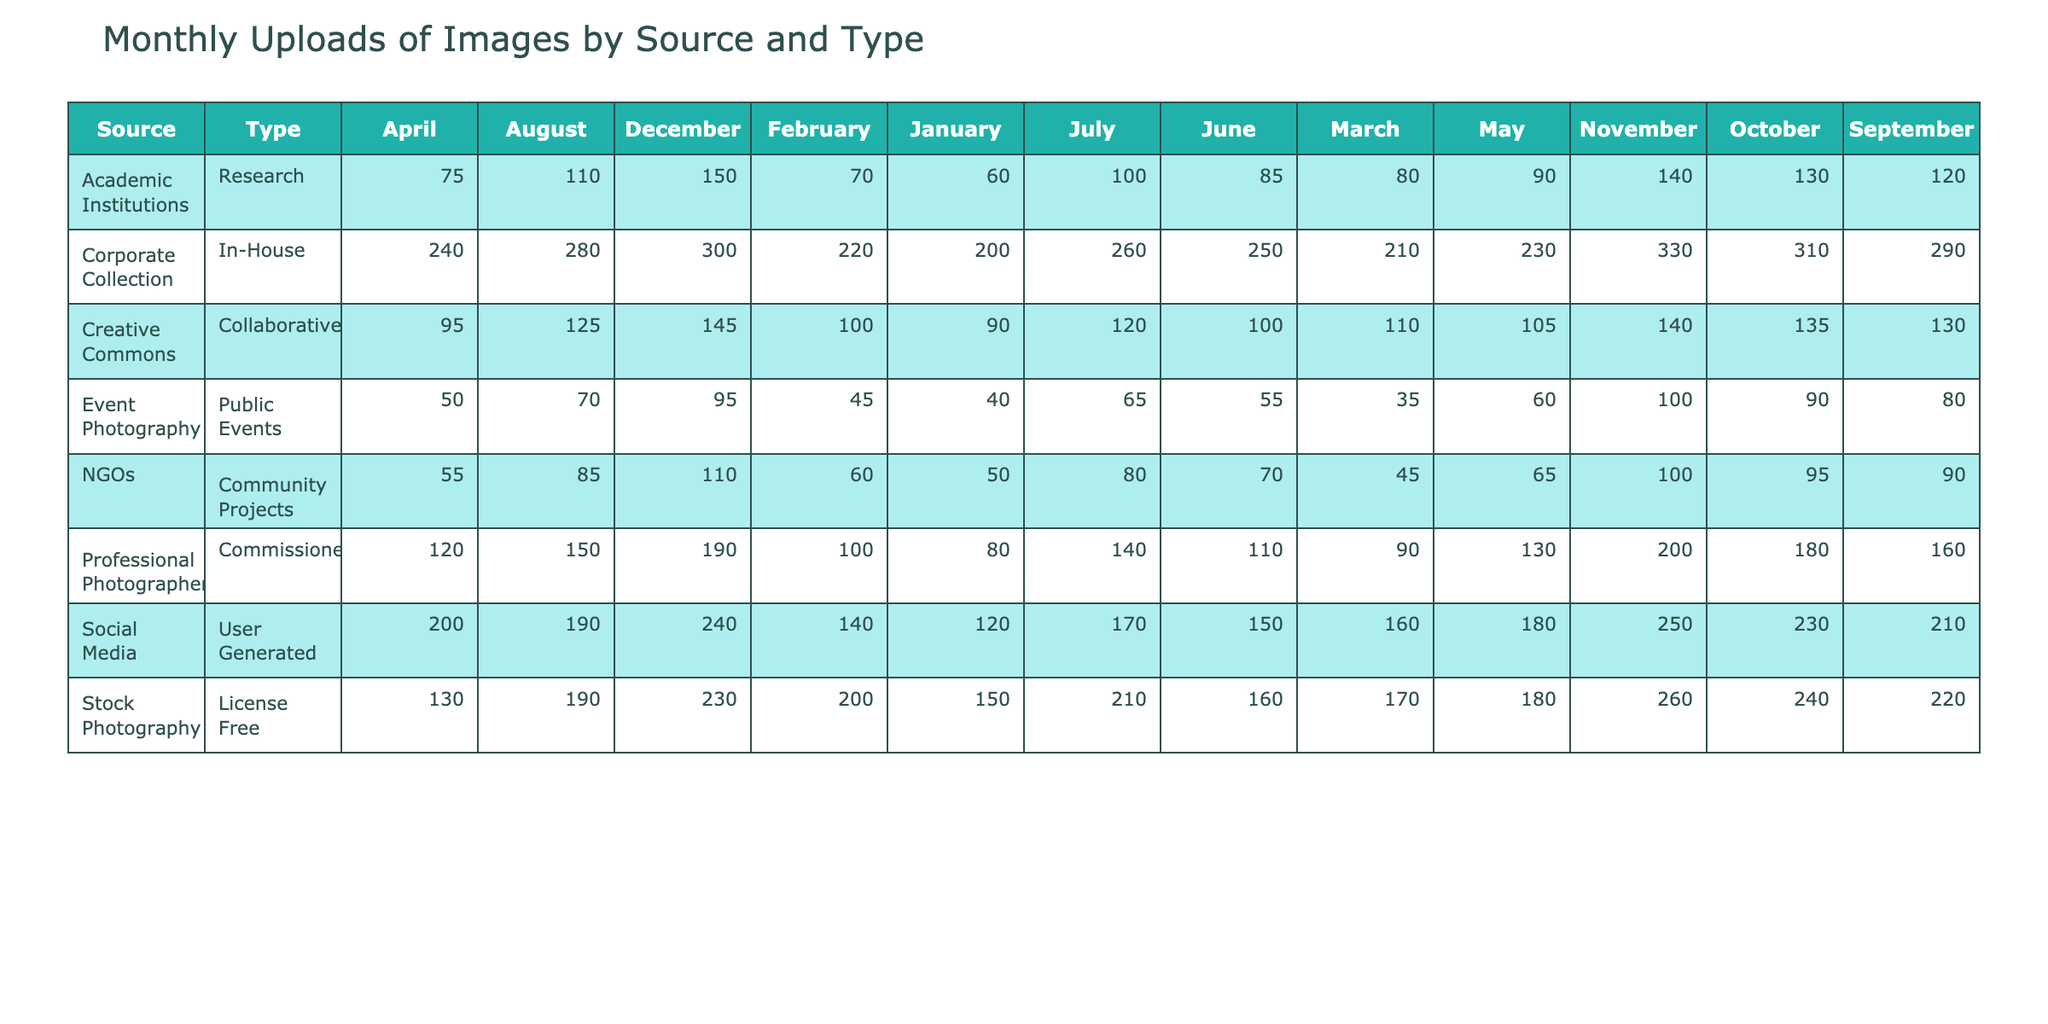What is the total number of uploads for Corporate Collection in December? The table shows that the Corporate Collection in December has 300 uploads. Therefore, this is a direct retrieval from the table.
Answer: 300 Which source had the highest total uploads across all months? To find this, we sum the uploads for each source. Corporate Collection has the highest total with (200 + 220 + 210 + 240 + 230 + 250 + 260 + 280 + 290 + 310 + 330 + 300) = 3,360 uploads.
Answer: Corporate Collection Did Event Photography have more uploads in October than in December? Looking at the values, Event Photography had 90 uploads in October and 95 uploads in December. Since 90 is less than 95, the answer is no.
Answer: No What is the average number of uploads per month for Professional Photographer? The uploads for the Professional Photographer are (80 + 100 + 90 + 120 + 130 + 110 + 140 + 150 + 160 + 180 + 200 + 190) = 1,590. There are 12 months, so the average is 1,590 / 12 = 132.5.
Answer: 132.5 How many more uploads did Stock Photography have in September than Academic Institutions? The numbers from the table show Stock Photography had 220 uploads in September while Academic Institutions had 120 uploads. Calculating the difference, we have 220 - 120 = 100.
Answer: 100 Which type of uploads has the lowest average across all months? We calculate the average for each type: License Free (195), User Generated (185), Commissioned (155), In-House (275), Research (105), Community Projects (75), Collaborative (126), Public Events (69.375). The lowest average is for Public Events at approximately 69.375.
Answer: Public Events Did Social Media uploads increase in May compared to April? In the table, Social Media had 200 uploads in April and 180 in May. Since 180 is less than 200, there was a decrease.
Answer: No Which source type had the highest monthly upload in July? Looking at the values for July: Stock Photography (210), Social Media (170), Professional Photographer (140), Corporate Collection (260), Academic Institutions (100), NGOs (80), Creative Commons (120), Event Photography (65). Corporate Collection had the highest with 260 uploads.
Answer: Corporate Collection 